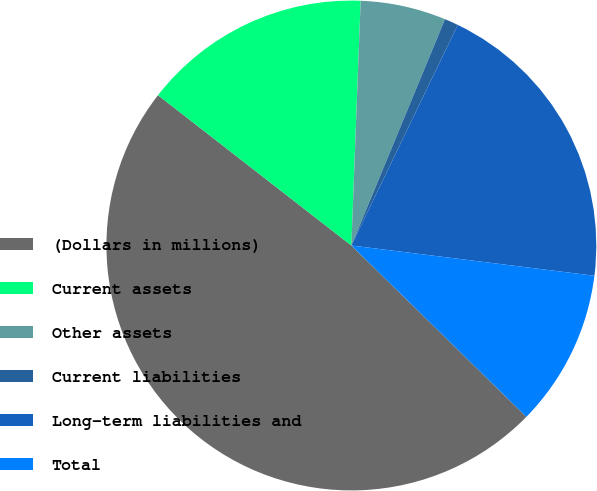Convert chart to OTSL. <chart><loc_0><loc_0><loc_500><loc_500><pie_chart><fcel>(Dollars in millions)<fcel>Current assets<fcel>Other assets<fcel>Current liabilities<fcel>Long-term liabilities and<fcel>Total<nl><fcel>48.19%<fcel>15.09%<fcel>5.64%<fcel>0.91%<fcel>19.82%<fcel>10.36%<nl></chart> 